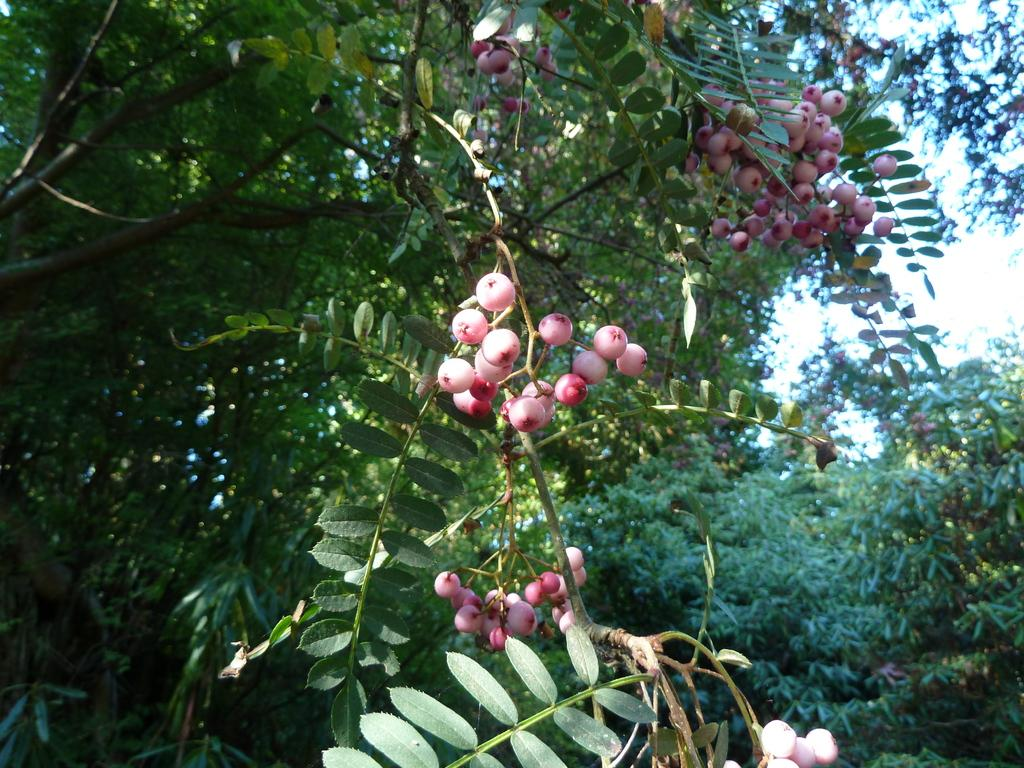What type of fruit can be seen on the plant in the image? There are berries on a plant in the image. What can be observed in the background of the image? There are many trees visible in the image. What type of music does the band play in the image? There is no band present in the image, so it is not possible to determine what type of music they might play. 